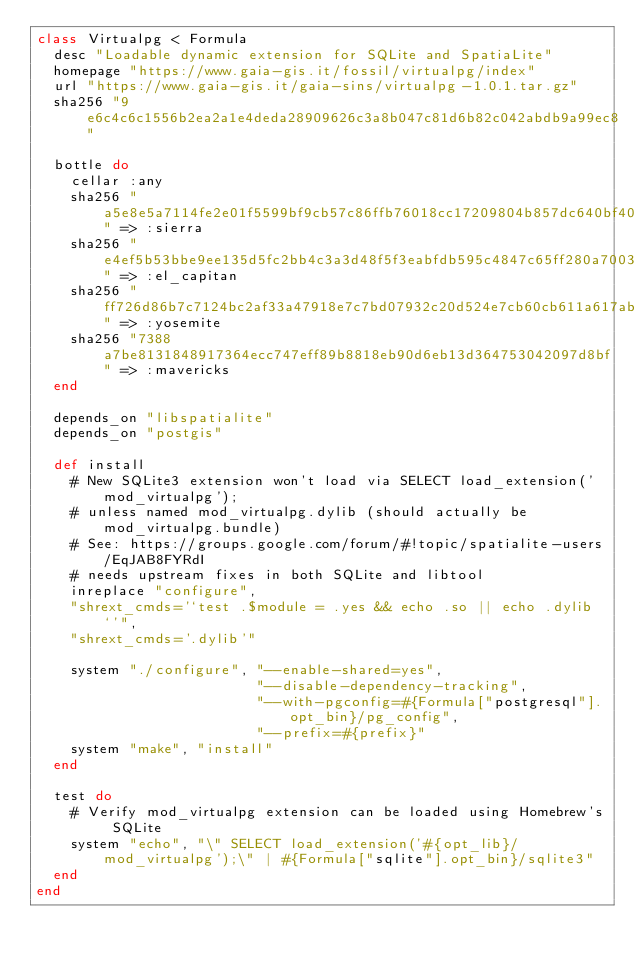<code> <loc_0><loc_0><loc_500><loc_500><_Ruby_>class Virtualpg < Formula
  desc "Loadable dynamic extension for SQLite and SpatiaLite"
  homepage "https://www.gaia-gis.it/fossil/virtualpg/index"
  url "https://www.gaia-gis.it/gaia-sins/virtualpg-1.0.1.tar.gz"
  sha256 "9e6c4c6c1556b2ea2a1e4deda28909626c3a8b047c81d6b82c042abdb9a99ec8"

  bottle do
    cellar :any
    sha256 "a5e8e5a7114fe2e01f5599bf9cb57c86ffb76018cc17209804b857dc640bf404" => :sierra
    sha256 "e4ef5b53bbe9ee135d5fc2bb4c3a3d48f5f3eabfdb595c4847c65ff280a70032" => :el_capitan
    sha256 "ff726d86b7c7124bc2af33a47918e7c7bd07932c20d524e7cb60cb611a617ab7" => :yosemite
    sha256 "7388a7be8131848917364ecc747eff89b8818eb90d6eb13d364753042097d8bf" => :mavericks
  end

  depends_on "libspatialite"
  depends_on "postgis"

  def install
    # New SQLite3 extension won't load via SELECT load_extension('mod_virtualpg');
    # unless named mod_virtualpg.dylib (should actually be mod_virtualpg.bundle)
    # See: https://groups.google.com/forum/#!topic/spatialite-users/EqJAB8FYRdI
    # needs upstream fixes in both SQLite and libtool
    inreplace "configure",
    "shrext_cmds='`test .$module = .yes && echo .so || echo .dylib`'",
    "shrext_cmds='.dylib'"

    system "./configure", "--enable-shared=yes",
                          "--disable-dependency-tracking",
                          "--with-pgconfig=#{Formula["postgresql"].opt_bin}/pg_config",
                          "--prefix=#{prefix}"
    system "make", "install"
  end

  test do
    # Verify mod_virtualpg extension can be loaded using Homebrew's SQLite
    system "echo", "\" SELECT load_extension('#{opt_lib}/mod_virtualpg');\" | #{Formula["sqlite"].opt_bin}/sqlite3"
  end
end
</code> 